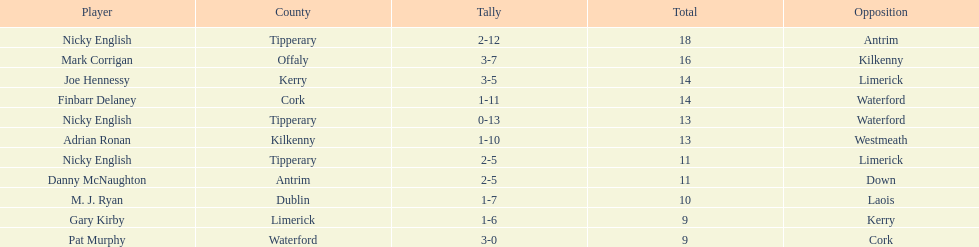What is the total number of points scored by joe hennessy and finbarr delaney? 14. 